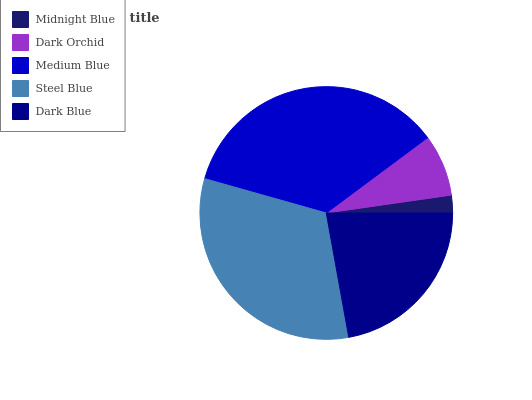Is Midnight Blue the minimum?
Answer yes or no. Yes. Is Medium Blue the maximum?
Answer yes or no. Yes. Is Dark Orchid the minimum?
Answer yes or no. No. Is Dark Orchid the maximum?
Answer yes or no. No. Is Dark Orchid greater than Midnight Blue?
Answer yes or no. Yes. Is Midnight Blue less than Dark Orchid?
Answer yes or no. Yes. Is Midnight Blue greater than Dark Orchid?
Answer yes or no. No. Is Dark Orchid less than Midnight Blue?
Answer yes or no. No. Is Dark Blue the high median?
Answer yes or no. Yes. Is Dark Blue the low median?
Answer yes or no. Yes. Is Steel Blue the high median?
Answer yes or no. No. Is Medium Blue the low median?
Answer yes or no. No. 